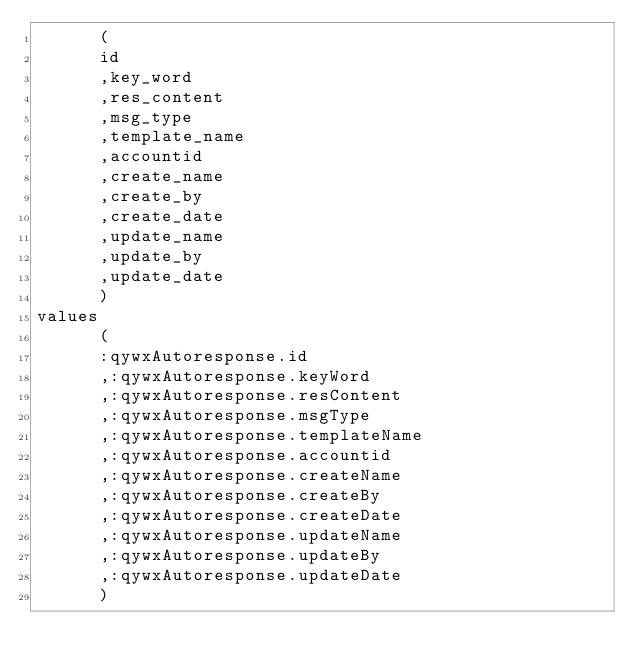<code> <loc_0><loc_0><loc_500><loc_500><_SQL_>      ( 
      id                            
      ,key_word                       
      ,res_content                    
      ,msg_type                       
      ,template_name                  
      ,accountid                      
      ,create_name                    
      ,create_by                      
      ,create_date                    
      ,update_name                    
      ,update_by                      
      ,update_date                    
      ) 
values
      (
      :qywxAutoresponse.id                            
      ,:qywxAutoresponse.keyWord                       
      ,:qywxAutoresponse.resContent                    
      ,:qywxAutoresponse.msgType                       
      ,:qywxAutoresponse.templateName                  
      ,:qywxAutoresponse.accountid                     
      ,:qywxAutoresponse.createName                    
      ,:qywxAutoresponse.createBy                      
      ,:qywxAutoresponse.createDate                    
      ,:qywxAutoresponse.updateName                    
      ,:qywxAutoresponse.updateBy                      
      ,:qywxAutoresponse.updateDate                    
      )</code> 